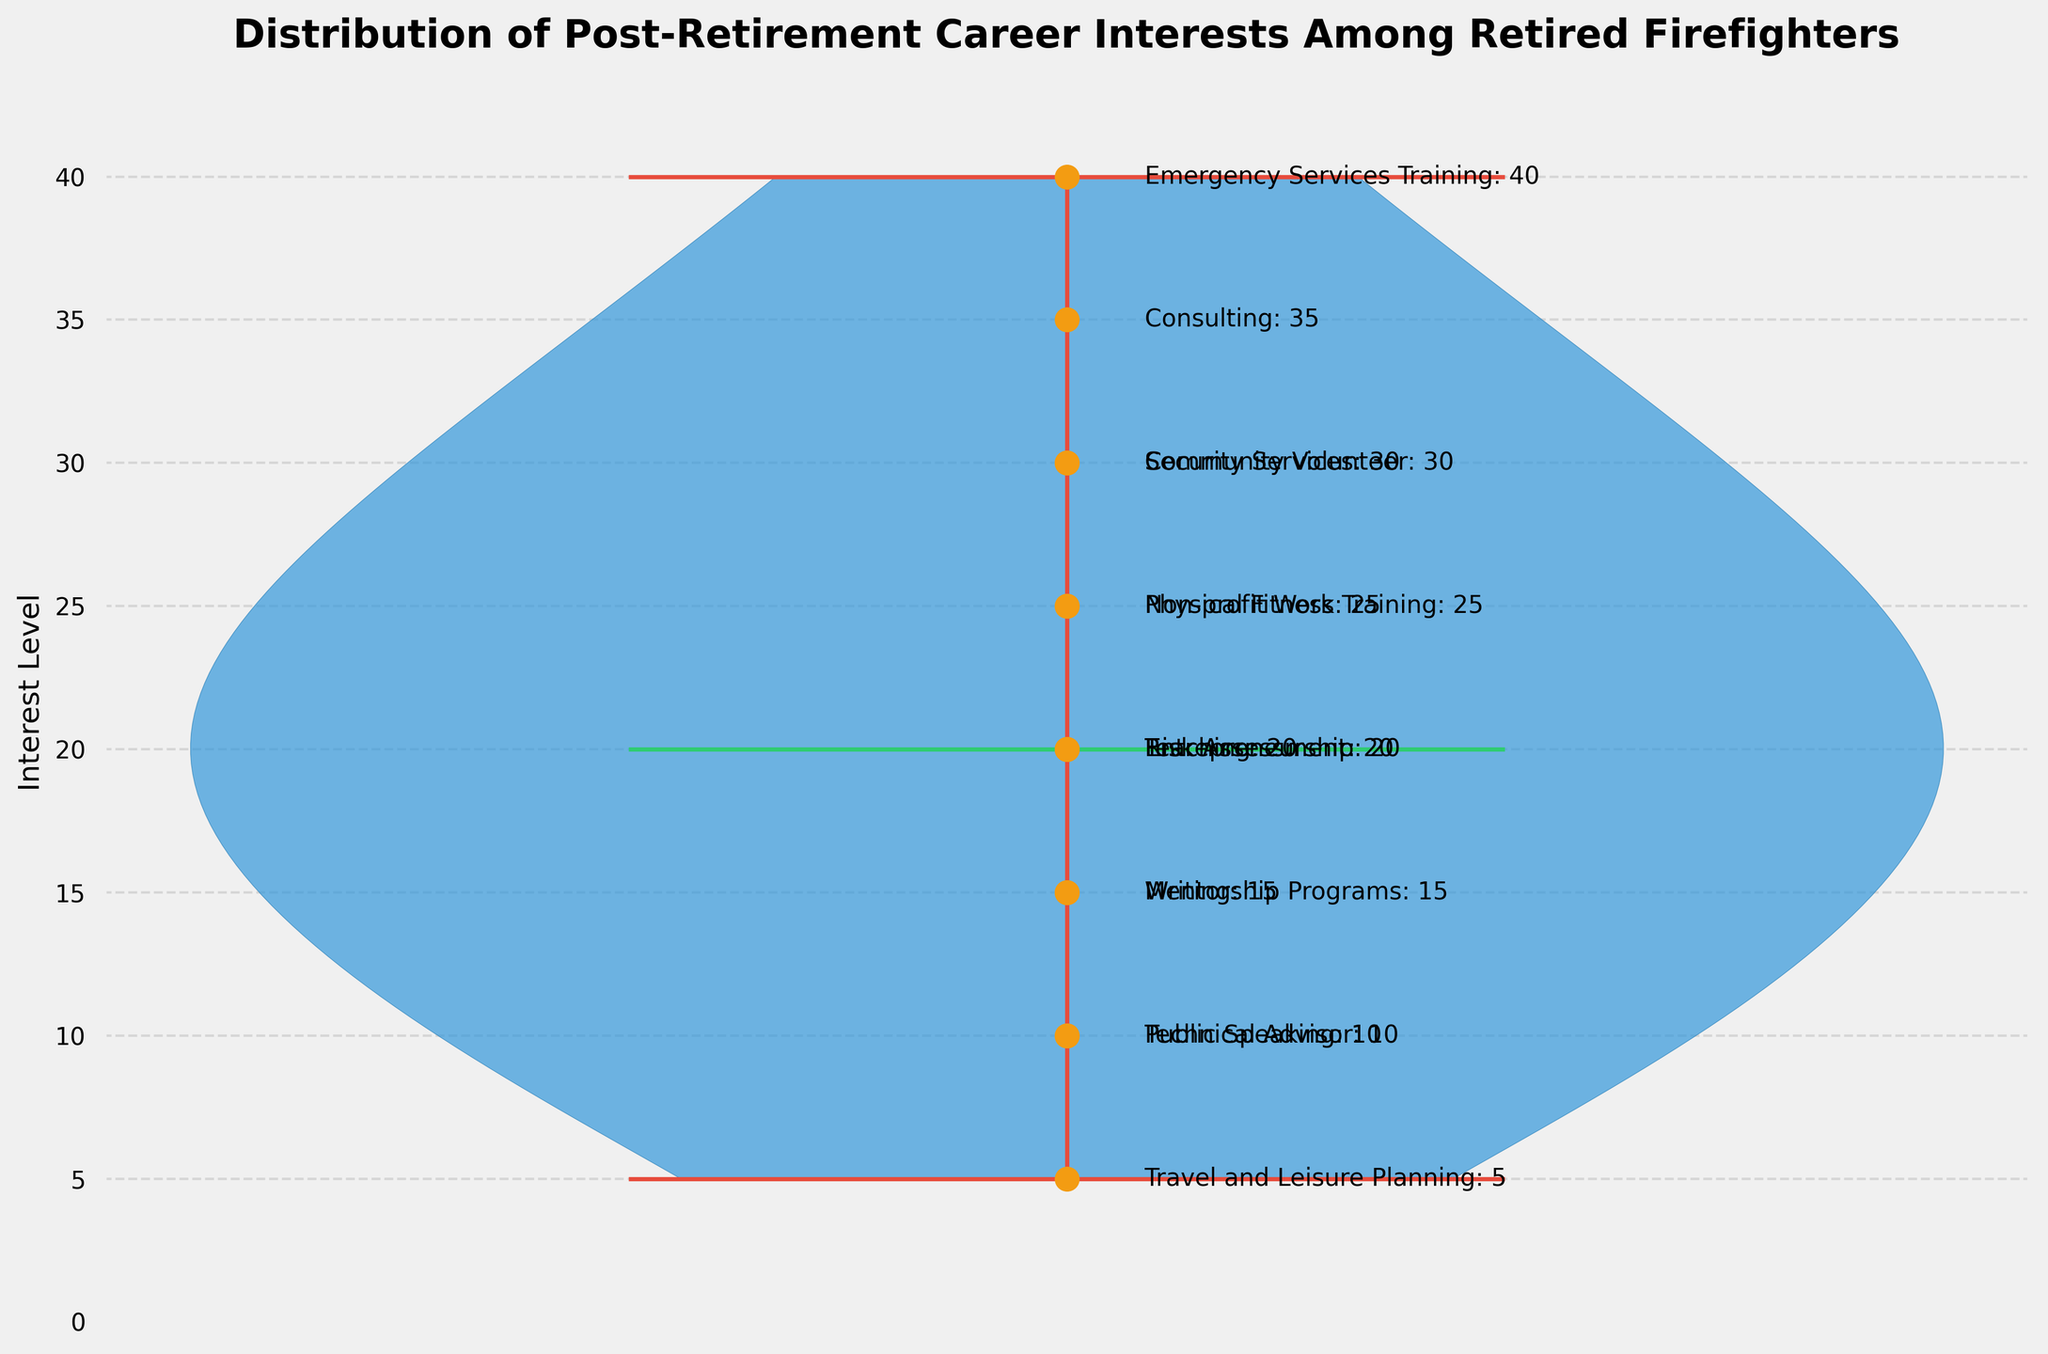What is the title of the figure? The title is the heading text above the plot, which states what the figure represents.
Answer: Distribution of Post-Retirement Career Interests Among Retired Firefighters Which category has the highest interest level? Identify the category with the highest numerical value indicated in the figure.
Answer: Emergency Services Training How are the median values represented in the violin plot? Look for the element that marks the middle value of the distribution inside the violin shape.
Answer: Green line Which category has the lowest interest level? Identify the category with the smallest numerical value indicated in the figure.
Answer: Travel and Leisure Planning How many categories have an interest level of 30? Count the number of data points identified with an interest level of 30 in the figure.
Answer: Two What range of interest levels is visible in the figure? Determine the lowest and highest values shown along the y-axis.
Answer: 5 to 40 What is the mean interest level of the categories with values below 20? Identify categories with interest levels below 20, sum their values, and divide by the count. E.g., (10 + 15 + 10 + 5) / 4.
Answer: 10 Which categories have an interest level above 25? Identify and list categories with interest levels greater than 25 based on the figure annotations.
Answer: Consulting, Emergency Services Training, Security Services, Community Volunteer Does the figure show categories with equal interest levels? If so, list them. Compare the interest levels of categories and look for identical values based on the position of the scatter points.
Answer: Teaching and Entrepreneurship, Writing and Mentorship Programs How does the distribution of interest levels appear in the violin plot? Describe the overall shape and spread of the data within the violin plot envelope.
Answer: Skewed towards higher levels 